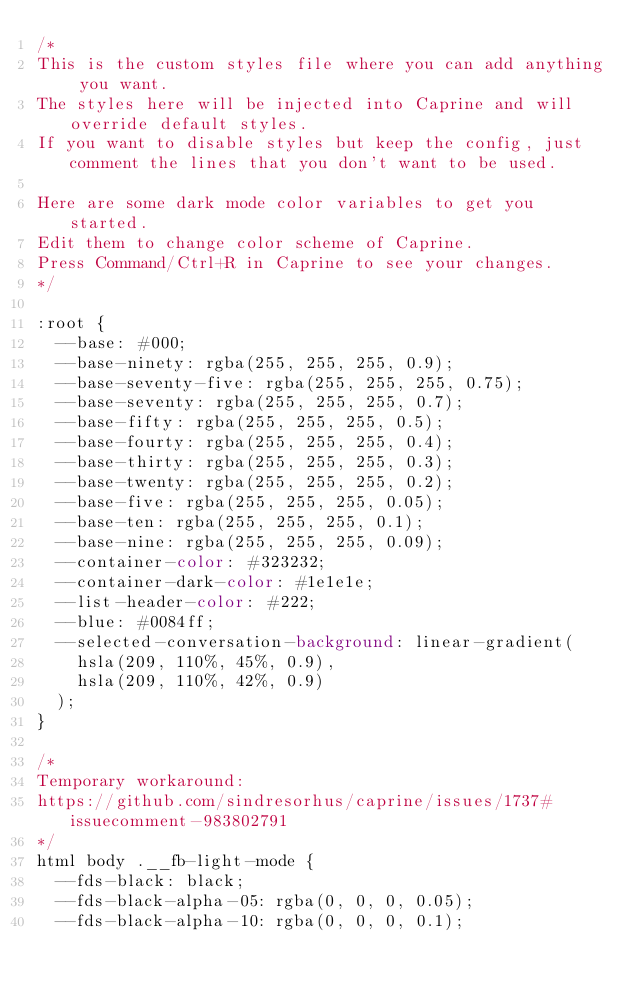<code> <loc_0><loc_0><loc_500><loc_500><_CSS_>/*
This is the custom styles file where you can add anything you want.
The styles here will be injected into Caprine and will override default styles.
If you want to disable styles but keep the config, just comment the lines that you don't want to be used.

Here are some dark mode color variables to get you started.
Edit them to change color scheme of Caprine.
Press Command/Ctrl+R in Caprine to see your changes.
*/

:root {
  --base: #000;
  --base-ninety: rgba(255, 255, 255, 0.9);
  --base-seventy-five: rgba(255, 255, 255, 0.75);
  --base-seventy: rgba(255, 255, 255, 0.7);
  --base-fifty: rgba(255, 255, 255, 0.5);
  --base-fourty: rgba(255, 255, 255, 0.4);
  --base-thirty: rgba(255, 255, 255, 0.3);
  --base-twenty: rgba(255, 255, 255, 0.2);
  --base-five: rgba(255, 255, 255, 0.05);
  --base-ten: rgba(255, 255, 255, 0.1);
  --base-nine: rgba(255, 255, 255, 0.09);
  --container-color: #323232;
  --container-dark-color: #1e1e1e;
  --list-header-color: #222;
  --blue: #0084ff;
  --selected-conversation-background: linear-gradient(
    hsla(209, 110%, 45%, 0.9),
    hsla(209, 110%, 42%, 0.9)
  );
}

/*
Temporary workaround:
https://github.com/sindresorhus/caprine/issues/1737#issuecomment-983802791
*/
html body .__fb-light-mode {
  --fds-black: black;
  --fds-black-alpha-05: rgba(0, 0, 0, 0.05);
  --fds-black-alpha-10: rgba(0, 0, 0, 0.1);</code> 